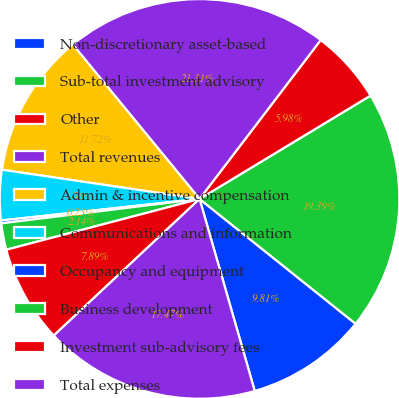Convert chart to OTSL. <chart><loc_0><loc_0><loc_500><loc_500><pie_chart><fcel>Non-discretionary asset-based<fcel>Sub-total investment advisory<fcel>Other<fcel>Total revenues<fcel>Admin & incentive compensation<fcel>Communications and information<fcel>Occupancy and equipment<fcel>Business development<fcel>Investment sub-advisory fees<fcel>Total expenses<nl><fcel>9.81%<fcel>19.39%<fcel>5.98%<fcel>21.31%<fcel>11.72%<fcel>4.06%<fcel>0.23%<fcel>2.14%<fcel>7.89%<fcel>17.47%<nl></chart> 